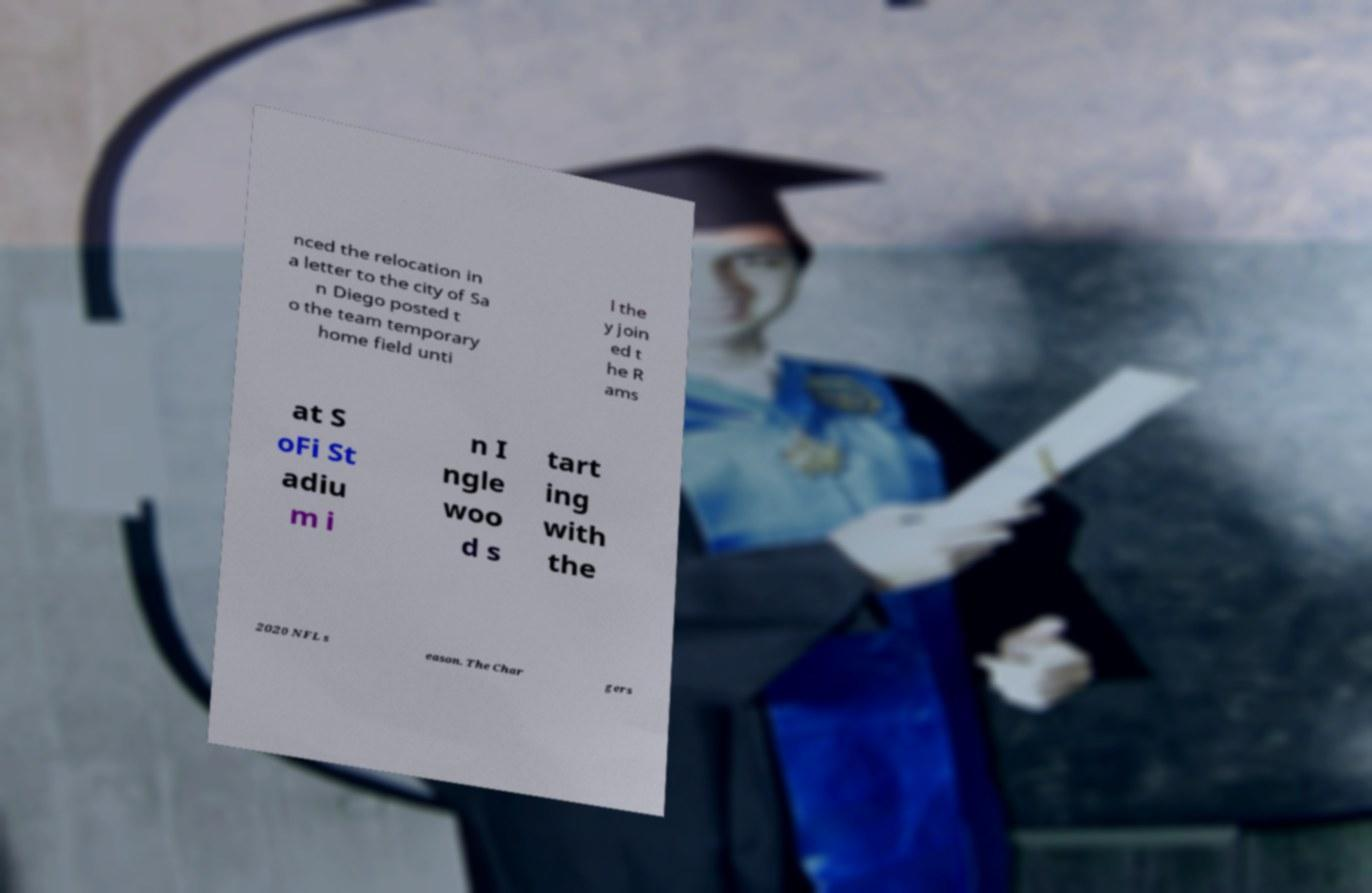There's text embedded in this image that I need extracted. Can you transcribe it verbatim? nced the relocation in a letter to the city of Sa n Diego posted t o the team temporary home field unti l the y join ed t he R ams at S oFi St adiu m i n I ngle woo d s tart ing with the 2020 NFL s eason. The Char gers 